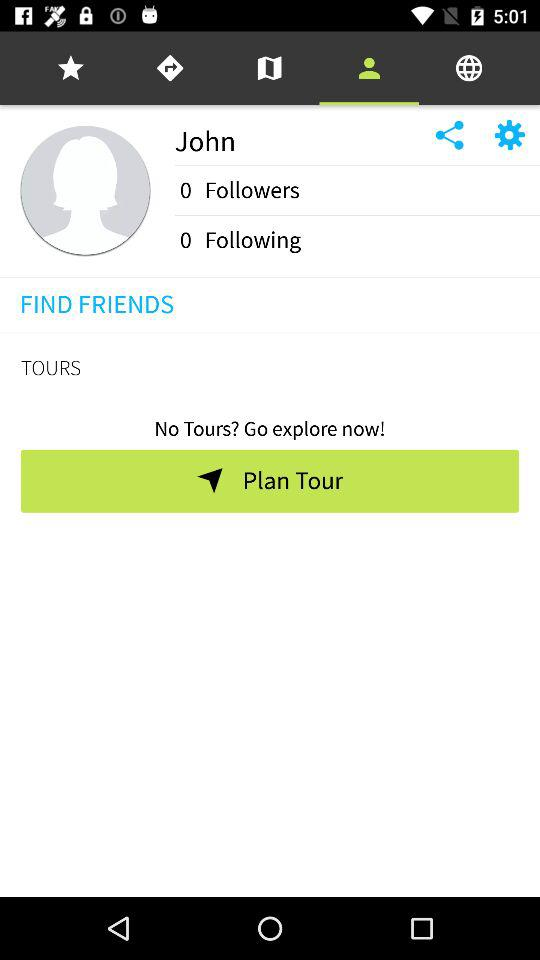What is the name of the user? The name of the user is John. 